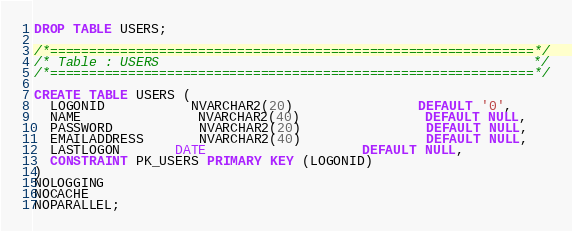Convert code to text. <code><loc_0><loc_0><loc_500><loc_500><_SQL_>DROP TABLE USERS;

/*==============================================================*/
/* Table : USERS                                                */
/*==============================================================*/

CREATE TABLE USERS (
  LOGONID 	 	   NVARCHAR2(20) 				DEFAULT '0',
  NAME 			   NVARCHAR2(40) 				DEFAULT NULL,
  PASSWORD 		   NVARCHAR2(20) 				DEFAULT NULL,
  EMAILADDRESS 	   NVARCHAR2(40) 				DEFAULT NULL,
  LASTLOGON 	   DATE 					DEFAULT NULL,
  CONSTRAINT PK_USERS PRIMARY KEY (LOGONID)
)
NOLOGGING
NOCACHE
NOPARALLEL;</code> 